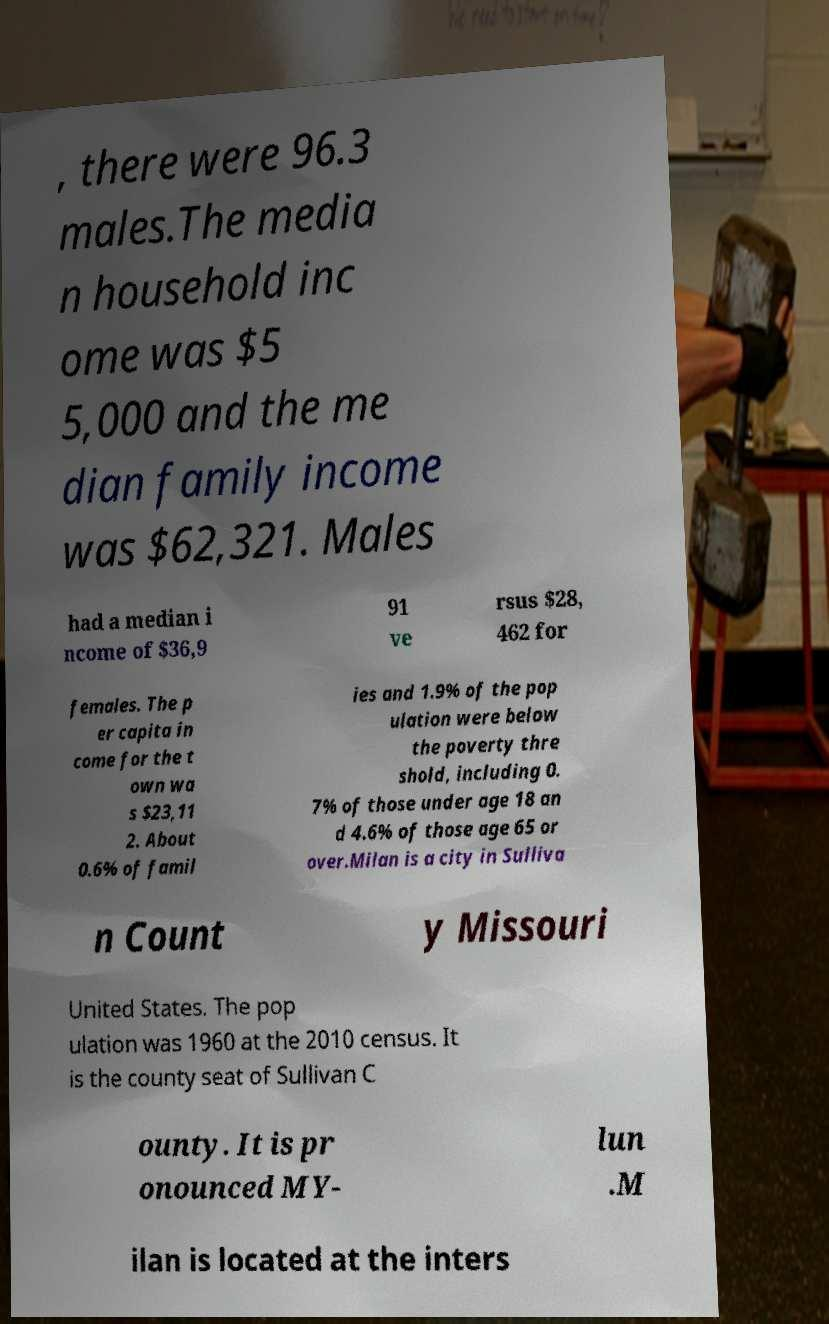Can you read and provide the text displayed in the image?This photo seems to have some interesting text. Can you extract and type it out for me? , there were 96.3 males.The media n household inc ome was $5 5,000 and the me dian family income was $62,321. Males had a median i ncome of $36,9 91 ve rsus $28, 462 for females. The p er capita in come for the t own wa s $23,11 2. About 0.6% of famil ies and 1.9% of the pop ulation were below the poverty thre shold, including 0. 7% of those under age 18 an d 4.6% of those age 65 or over.Milan is a city in Sulliva n Count y Missouri United States. The pop ulation was 1960 at the 2010 census. It is the county seat of Sullivan C ounty. It is pr onounced MY- lun .M ilan is located at the inters 